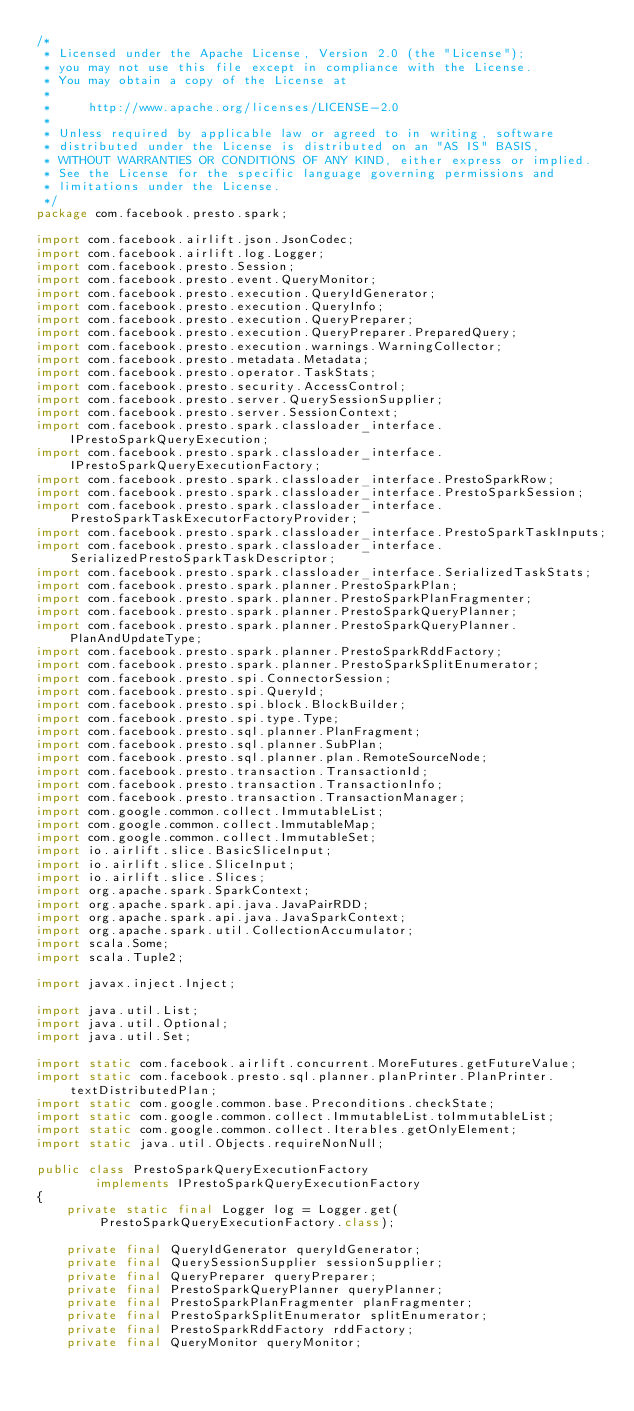<code> <loc_0><loc_0><loc_500><loc_500><_Java_>/*
 * Licensed under the Apache License, Version 2.0 (the "License");
 * you may not use this file except in compliance with the License.
 * You may obtain a copy of the License at
 *
 *     http://www.apache.org/licenses/LICENSE-2.0
 *
 * Unless required by applicable law or agreed to in writing, software
 * distributed under the License is distributed on an "AS IS" BASIS,
 * WITHOUT WARRANTIES OR CONDITIONS OF ANY KIND, either express or implied.
 * See the License for the specific language governing permissions and
 * limitations under the License.
 */
package com.facebook.presto.spark;

import com.facebook.airlift.json.JsonCodec;
import com.facebook.airlift.log.Logger;
import com.facebook.presto.Session;
import com.facebook.presto.event.QueryMonitor;
import com.facebook.presto.execution.QueryIdGenerator;
import com.facebook.presto.execution.QueryInfo;
import com.facebook.presto.execution.QueryPreparer;
import com.facebook.presto.execution.QueryPreparer.PreparedQuery;
import com.facebook.presto.execution.warnings.WarningCollector;
import com.facebook.presto.metadata.Metadata;
import com.facebook.presto.operator.TaskStats;
import com.facebook.presto.security.AccessControl;
import com.facebook.presto.server.QuerySessionSupplier;
import com.facebook.presto.server.SessionContext;
import com.facebook.presto.spark.classloader_interface.IPrestoSparkQueryExecution;
import com.facebook.presto.spark.classloader_interface.IPrestoSparkQueryExecutionFactory;
import com.facebook.presto.spark.classloader_interface.PrestoSparkRow;
import com.facebook.presto.spark.classloader_interface.PrestoSparkSession;
import com.facebook.presto.spark.classloader_interface.PrestoSparkTaskExecutorFactoryProvider;
import com.facebook.presto.spark.classloader_interface.PrestoSparkTaskInputs;
import com.facebook.presto.spark.classloader_interface.SerializedPrestoSparkTaskDescriptor;
import com.facebook.presto.spark.classloader_interface.SerializedTaskStats;
import com.facebook.presto.spark.planner.PrestoSparkPlan;
import com.facebook.presto.spark.planner.PrestoSparkPlanFragmenter;
import com.facebook.presto.spark.planner.PrestoSparkQueryPlanner;
import com.facebook.presto.spark.planner.PrestoSparkQueryPlanner.PlanAndUpdateType;
import com.facebook.presto.spark.planner.PrestoSparkRddFactory;
import com.facebook.presto.spark.planner.PrestoSparkSplitEnumerator;
import com.facebook.presto.spi.ConnectorSession;
import com.facebook.presto.spi.QueryId;
import com.facebook.presto.spi.block.BlockBuilder;
import com.facebook.presto.spi.type.Type;
import com.facebook.presto.sql.planner.PlanFragment;
import com.facebook.presto.sql.planner.SubPlan;
import com.facebook.presto.sql.planner.plan.RemoteSourceNode;
import com.facebook.presto.transaction.TransactionId;
import com.facebook.presto.transaction.TransactionInfo;
import com.facebook.presto.transaction.TransactionManager;
import com.google.common.collect.ImmutableList;
import com.google.common.collect.ImmutableMap;
import com.google.common.collect.ImmutableSet;
import io.airlift.slice.BasicSliceInput;
import io.airlift.slice.SliceInput;
import io.airlift.slice.Slices;
import org.apache.spark.SparkContext;
import org.apache.spark.api.java.JavaPairRDD;
import org.apache.spark.api.java.JavaSparkContext;
import org.apache.spark.util.CollectionAccumulator;
import scala.Some;
import scala.Tuple2;

import javax.inject.Inject;

import java.util.List;
import java.util.Optional;
import java.util.Set;

import static com.facebook.airlift.concurrent.MoreFutures.getFutureValue;
import static com.facebook.presto.sql.planner.planPrinter.PlanPrinter.textDistributedPlan;
import static com.google.common.base.Preconditions.checkState;
import static com.google.common.collect.ImmutableList.toImmutableList;
import static com.google.common.collect.Iterables.getOnlyElement;
import static java.util.Objects.requireNonNull;

public class PrestoSparkQueryExecutionFactory
        implements IPrestoSparkQueryExecutionFactory
{
    private static final Logger log = Logger.get(PrestoSparkQueryExecutionFactory.class);

    private final QueryIdGenerator queryIdGenerator;
    private final QuerySessionSupplier sessionSupplier;
    private final QueryPreparer queryPreparer;
    private final PrestoSparkQueryPlanner queryPlanner;
    private final PrestoSparkPlanFragmenter planFragmenter;
    private final PrestoSparkSplitEnumerator splitEnumerator;
    private final PrestoSparkRddFactory rddFactory;
    private final QueryMonitor queryMonitor;</code> 